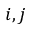<formula> <loc_0><loc_0><loc_500><loc_500>i , j</formula> 